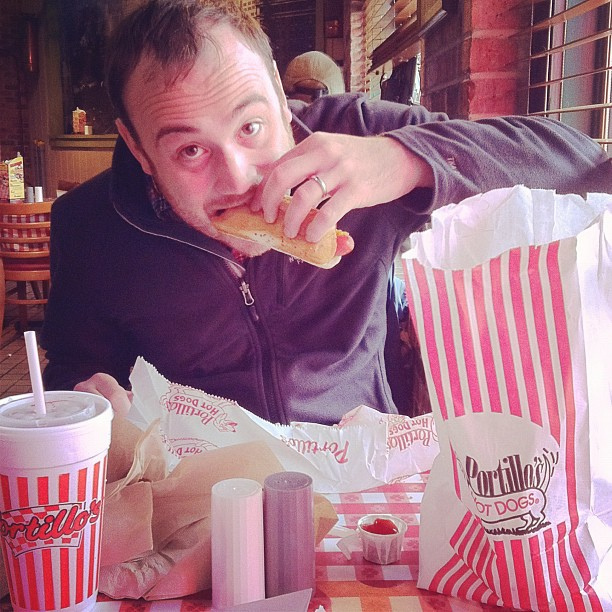Extract all visible text content from this image. DOGS Portillos 